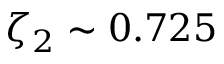<formula> <loc_0><loc_0><loc_500><loc_500>\zeta _ { 2 } \sim 0 . 7 2 5</formula> 